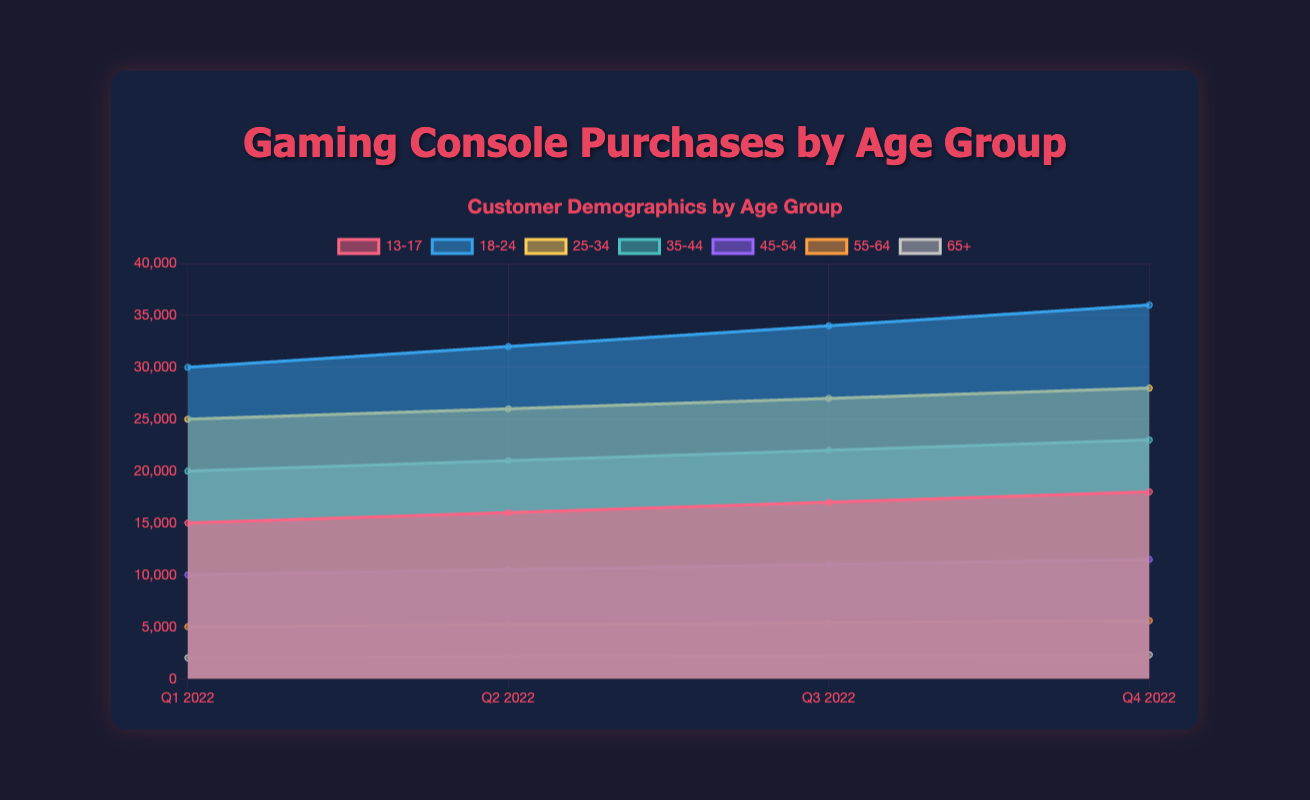What is the main title of the chart? The title of the chart is displayed prominently at the top in the header section.
Answer: Gaming Console Purchases by Age Group Which age group has the highest number of gaming console purchases in Q3 2022? By observing the height of the individual areas in Q3 2022, we can see that the age group with the largest area representation is 18-24.
Answer: 18-24 What is the total number of gaming console purchases in Q4 2022 for all age groups combined? Adding the values of all the age groups in Q4 2022: 18000 (13-17) + 36000 (18-24) + 28000 (25-34) + 23000 (35-44) + 11500 (45-54) + 5600 (55-64) + 2300 (65+). The total is 124400.
Answer: 124400 Which age group has shown the most growth from Q1 2022 to Q4 2022? To determine the age group with the most growth, we calculate the difference in purchases from Q1 to Q4 for each group and identify the maximum: (18000-15000)=3000, (36000-30000)=6000, (28000-25000)=3000, (23000-20000)=3000, (11500-10000)=1500, (5600-5000)=600, (2300-2000)=300. The 18-24 group has the highest growth.
Answer: 18-24 How did the gaming console purchases for the 25-34 age group change from Q2 2022 to Q3 2022? By deducting the Q2 2022 value from the Q3 2022 value for the 25-34 group: 27000 - 26000 = 1000, this indicates a positive change.
Answer: Increased by 1000 Between which quarters did the 45-54 age group see the highest increase in gaming console purchases? To find when the highest increase occurred, we calculate the differences between consecutive quarters for the 45-54 group: Q2-Q1=(10500-10000)=500, Q3-Q2=(11000-10500)=500, Q4-Q3=(11500-11000)=500. The increases are equal.
Answer: All increases of 500 Compare the purchases of age groups 18-24 and 35-44 in Q4 2022. Which group had more and by how much? Subtract the number of purchases of the 35-44 group from those of the 18-24 group in Q4 2022: 36000 - 23000 = 13000. Group 18-24 had more.
Answer: 18-24 had 13000 more What is the trend for the 55-64 age group from Q1 2022 to Q4 2022? Observing the data points for the 55-64 age group across the quarters, notice an increasing trend: Q1=5000, Q2=5200, Q3=5400, Q4=5600.
Answer: Increasing How does the 65+ age group's total purchases in 2022 compare to the 45-54 age group's total purchases in 2022? Calculate the total purchases for both groups across all quarters. For 65+: 2000+2100+2200+2300 = 8600. For 45-54: 10000+10500+11000+11500 = 43000.
Answer: The 45-54 age group purchased 34400 more consoles What is the color used to represent the 13-17 age group on the chart? The 13-17 age group is represented by a specific color which can be identified from the chart legend. It is a shade of red.
Answer: Red 